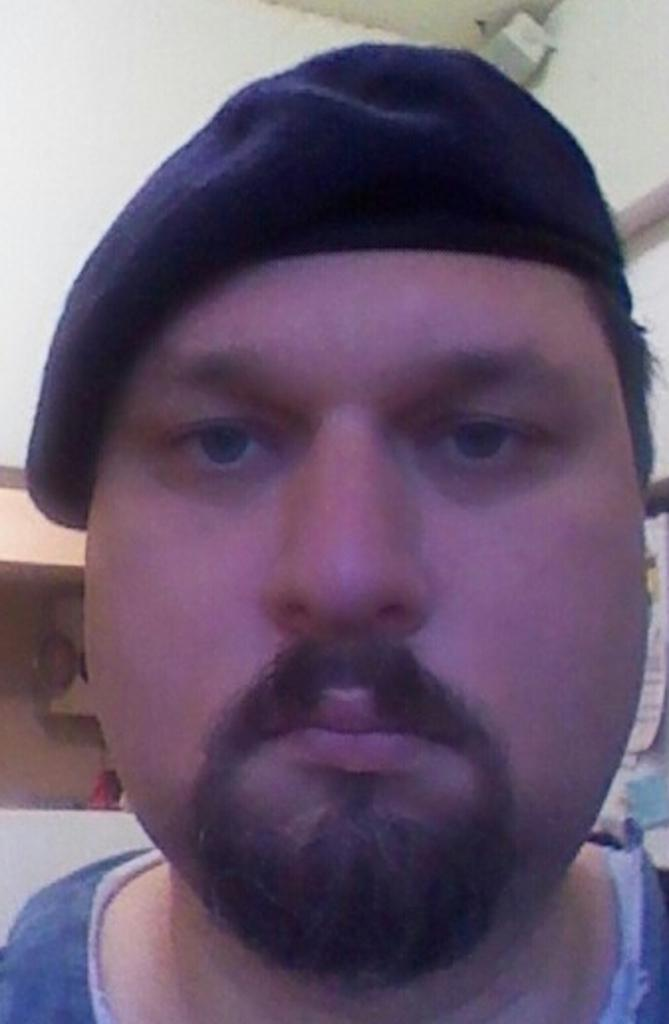What is the main subject of the image? There is a man's face in the front of the image. What can be seen in the background of the image? There is a wall in the background of the image. What is the man wearing on his head? The man is wearing a cap. How many beetles can be seen crawling on the wall in the image? There are no beetles visible in the image; it only features a man's face and a wall in the background. 